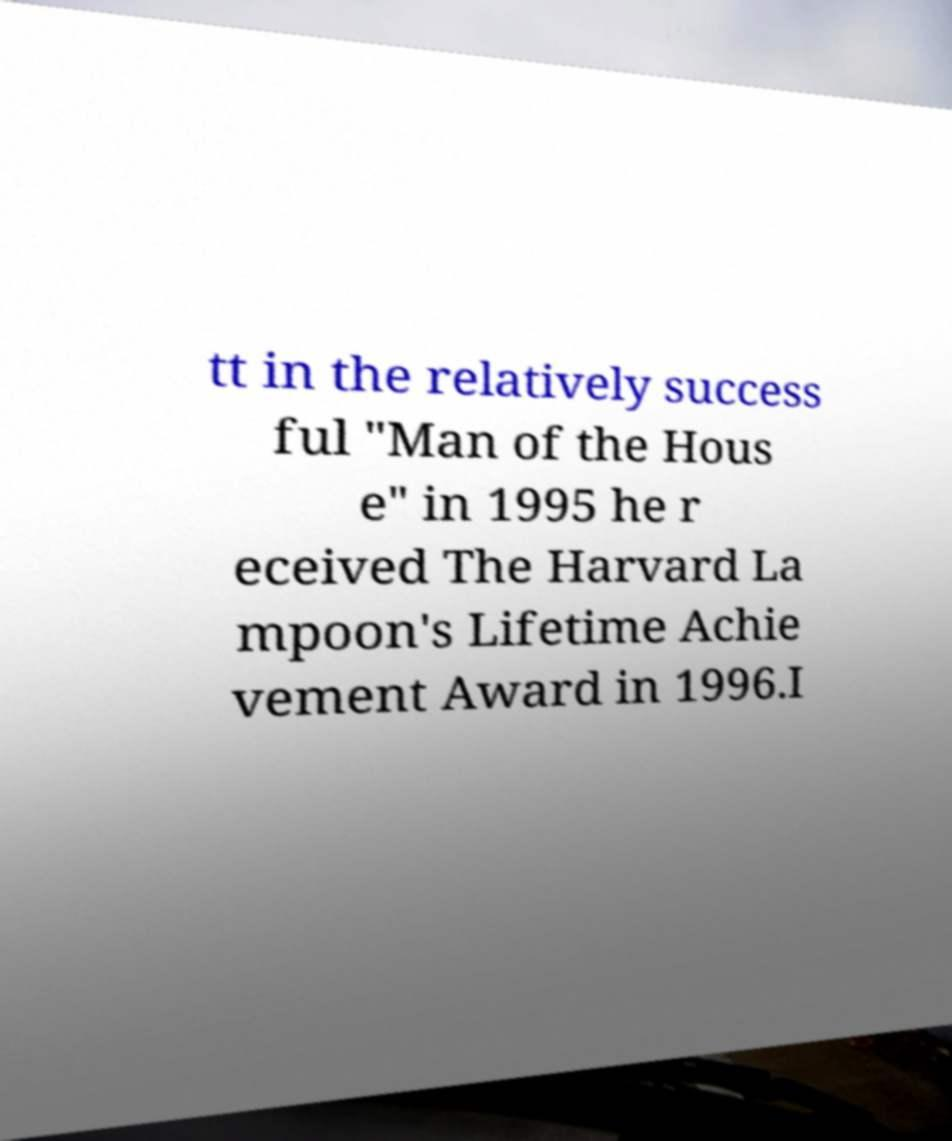There's text embedded in this image that I need extracted. Can you transcribe it verbatim? tt in the relatively success ful "Man of the Hous e" in 1995 he r eceived The Harvard La mpoon's Lifetime Achie vement Award in 1996.I 